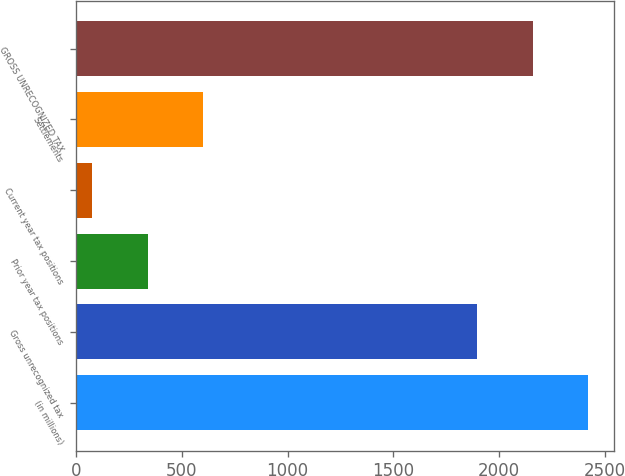Convert chart. <chart><loc_0><loc_0><loc_500><loc_500><bar_chart><fcel>(in millions)<fcel>Gross unrecognized tax<fcel>Prior year tax positions<fcel>Current year tax positions<fcel>Settlements<fcel>GROSS UNRECOGNIZED TAX<nl><fcel>2421.6<fcel>1896<fcel>337.8<fcel>75<fcel>600.6<fcel>2158.8<nl></chart> 